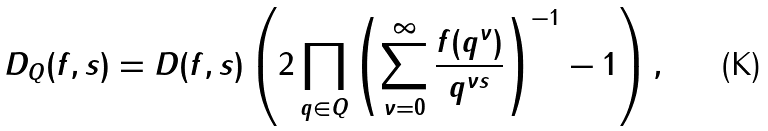<formula> <loc_0><loc_0><loc_500><loc_500>D _ { Q } ( f , s ) = D ( f , s ) \left ( 2 \prod _ { q \in Q } \left ( \sum _ { \nu = 0 } ^ { \infty } \frac { f ( q ^ { \nu } ) } { q ^ { \nu s } } \right ) ^ { - 1 } - 1 \right ) ,</formula> 